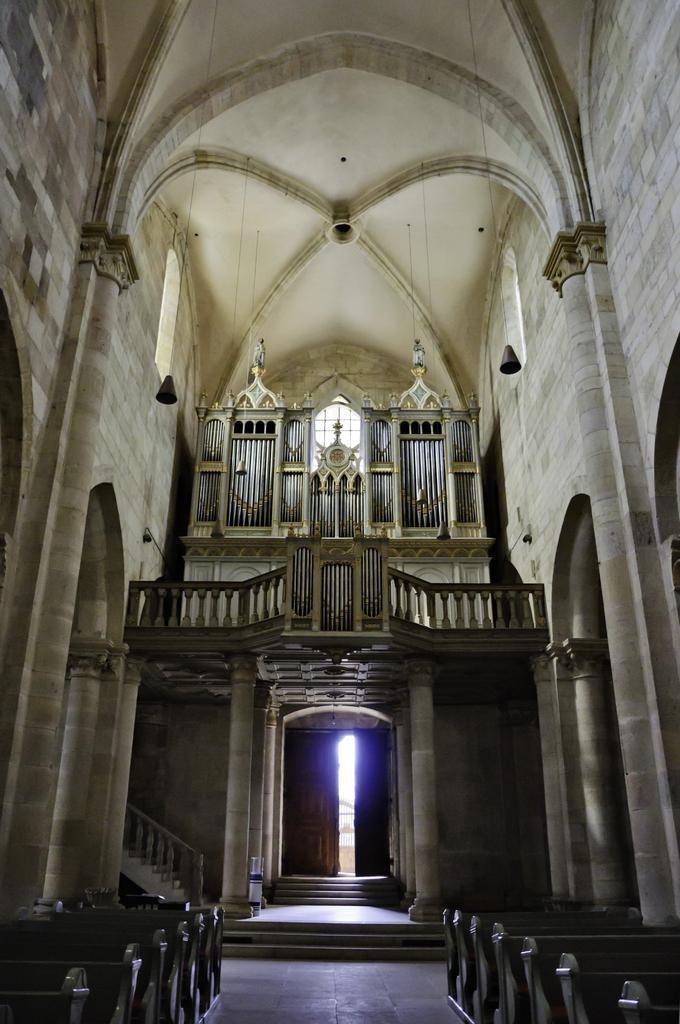Describe this image in one or two sentences. This is the inside view of a hall, in this hall there are benches, behind the benches there are stairs, around the benches there are pillars, at the top of the image there is a roof and some objects hanging, behind the stairs there is a wooden door, on top of the door there is a concrete fence balcony with some architectural designs behind that. 